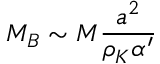Convert formula to latex. <formula><loc_0><loc_0><loc_500><loc_500>M _ { B } \sim M \frac { a ^ { 2 } } { \rho _ { K } \alpha ^ { \prime } }</formula> 